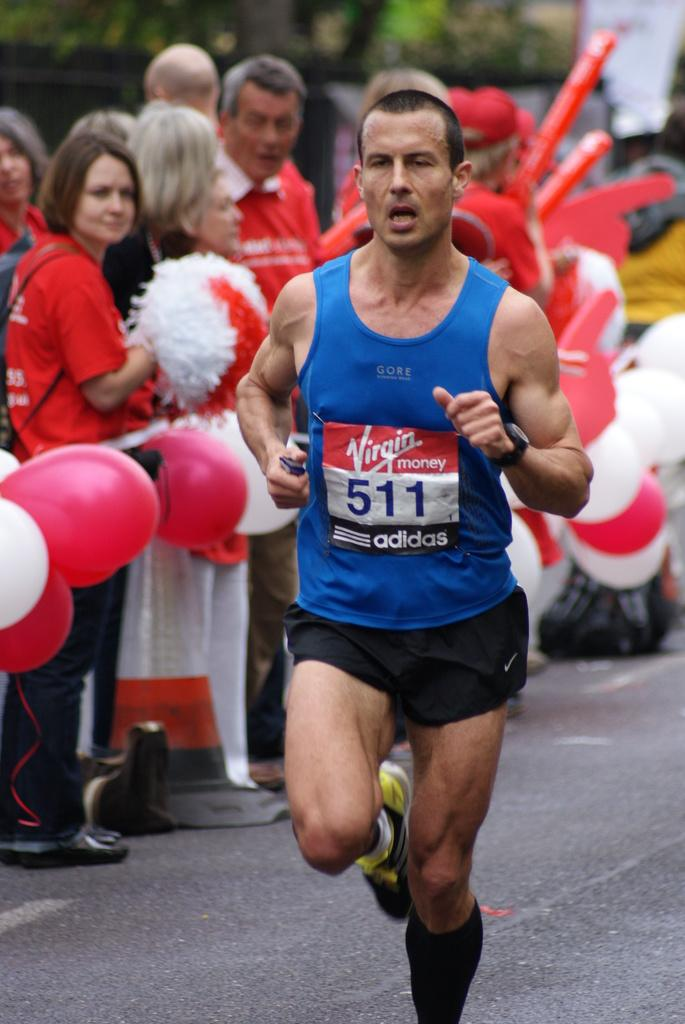<image>
Give a short and clear explanation of the subsequent image. Runner number 511 seems to be sponsored by Adidas. 